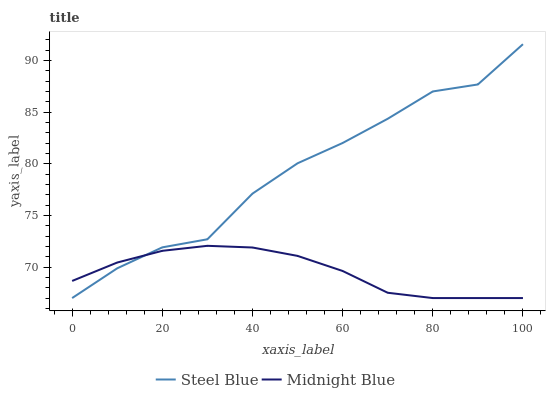Does Midnight Blue have the minimum area under the curve?
Answer yes or no. Yes. Does Midnight Blue have the maximum area under the curve?
Answer yes or no. No. Is Midnight Blue the roughest?
Answer yes or no. No. Does Midnight Blue have the highest value?
Answer yes or no. No. 